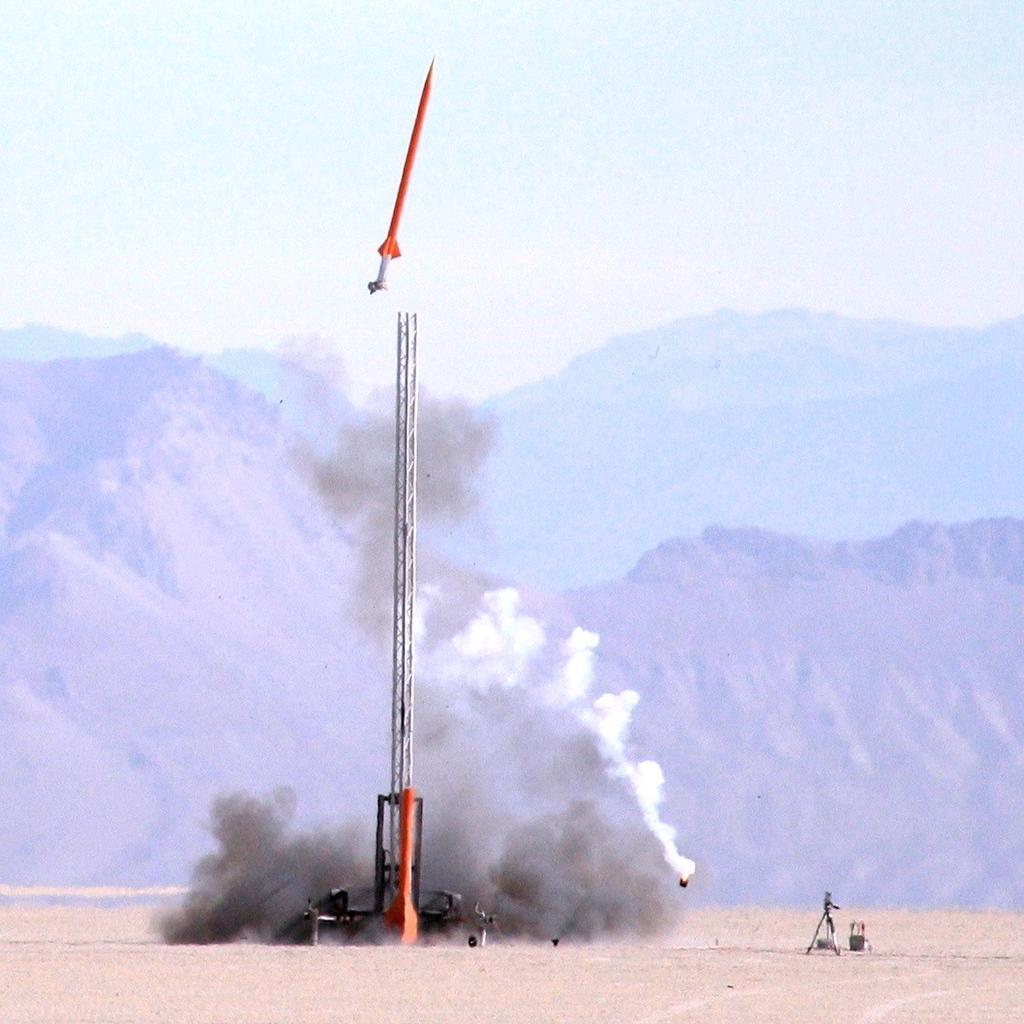In one or two sentences, can you explain what this image depicts? In the background we can see sky, hills. In this picture we can see objects on the ground. At the top we can see an object in the air. We can also see smoke. 